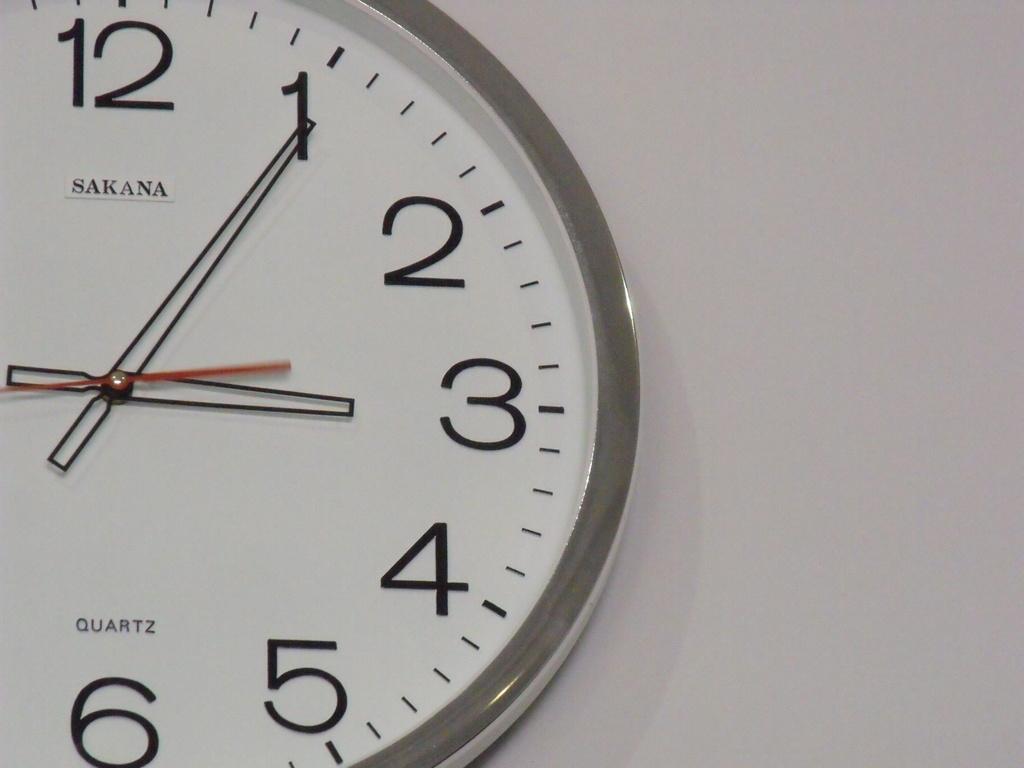What time is it?
Give a very brief answer. 3:05. What brand is this clock?
Provide a short and direct response. Sakana. 